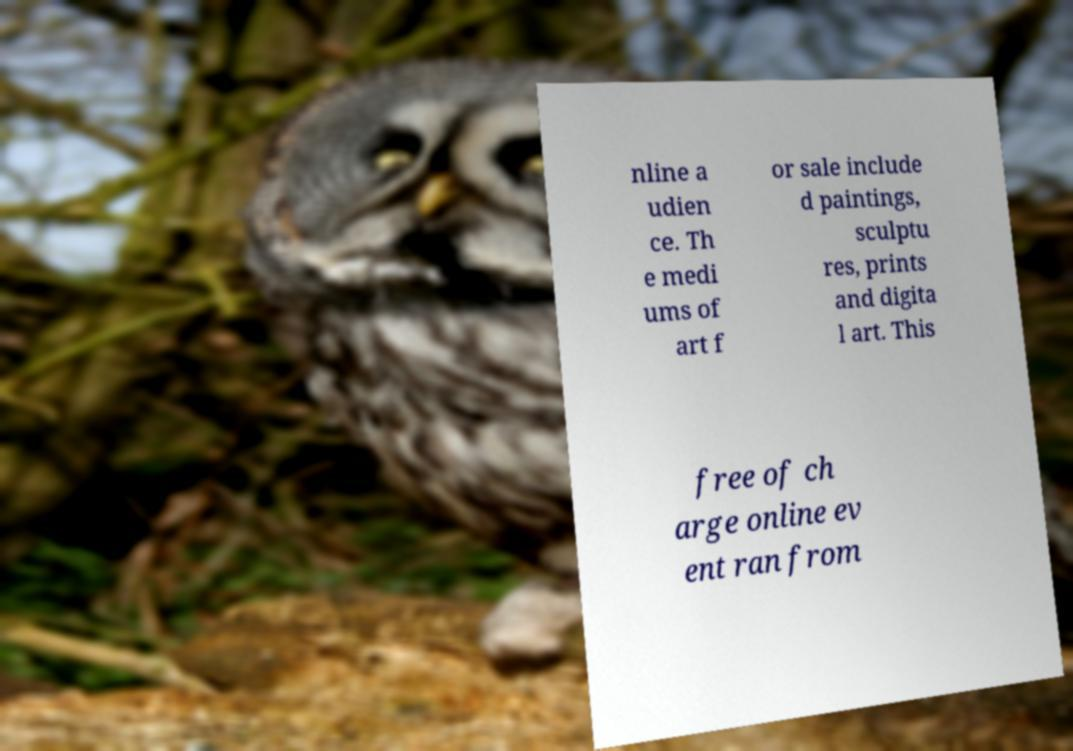Could you assist in decoding the text presented in this image and type it out clearly? nline a udien ce. Th e medi ums of art f or sale include d paintings, sculptu res, prints and digita l art. This free of ch arge online ev ent ran from 